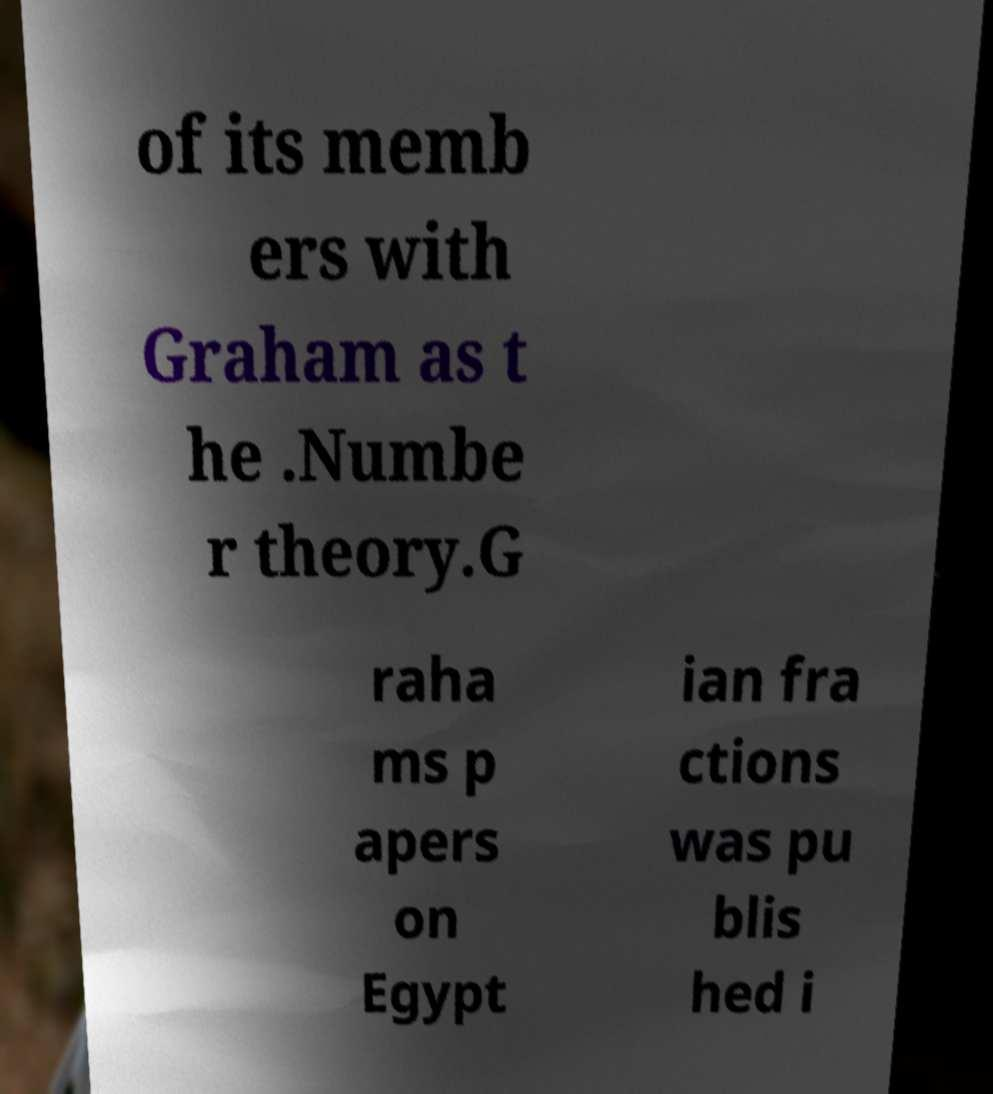Can you read and provide the text displayed in the image?This photo seems to have some interesting text. Can you extract and type it out for me? of its memb ers with Graham as t he .Numbe r theory.G raha ms p apers on Egypt ian fra ctions was pu blis hed i 